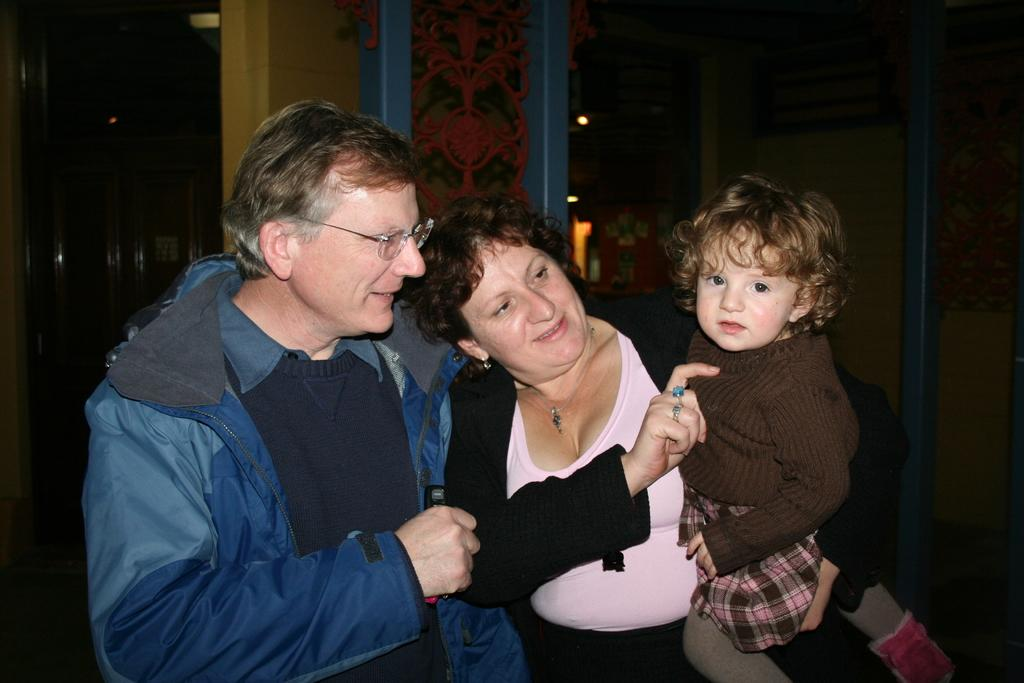What is the main subject of the image? The main subjects of the image are a man and a lady. Can you describe the man's attire in the image? The man is wearing a jacket and specs in the image. What is the lady doing in the image? The lady is holding a child in the image. What can be seen in the background of the image? There is a wall with decorations in the background of the image. What type of store can be seen in the background of the image? There is no store visible in the background of the image; it features a wall with decorations. How does the wind affect the man and the lady in the image? There is no mention of wind in the image, so we cannot determine its effect on the subjects. 